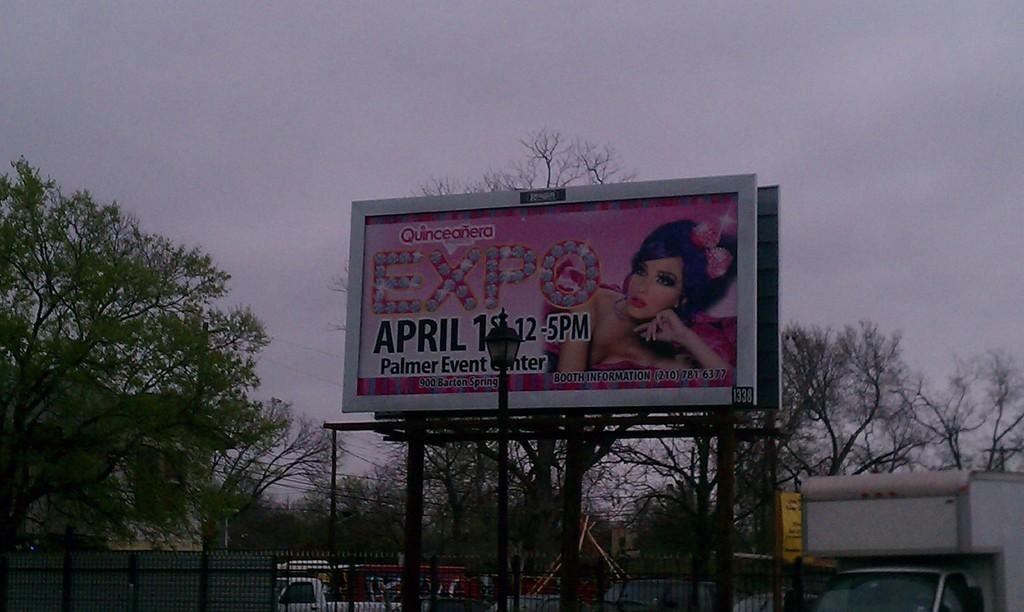<image>
Relay a brief, clear account of the picture shown. Quinceanera party at the Expo Palmer Event Center on April 1st. 